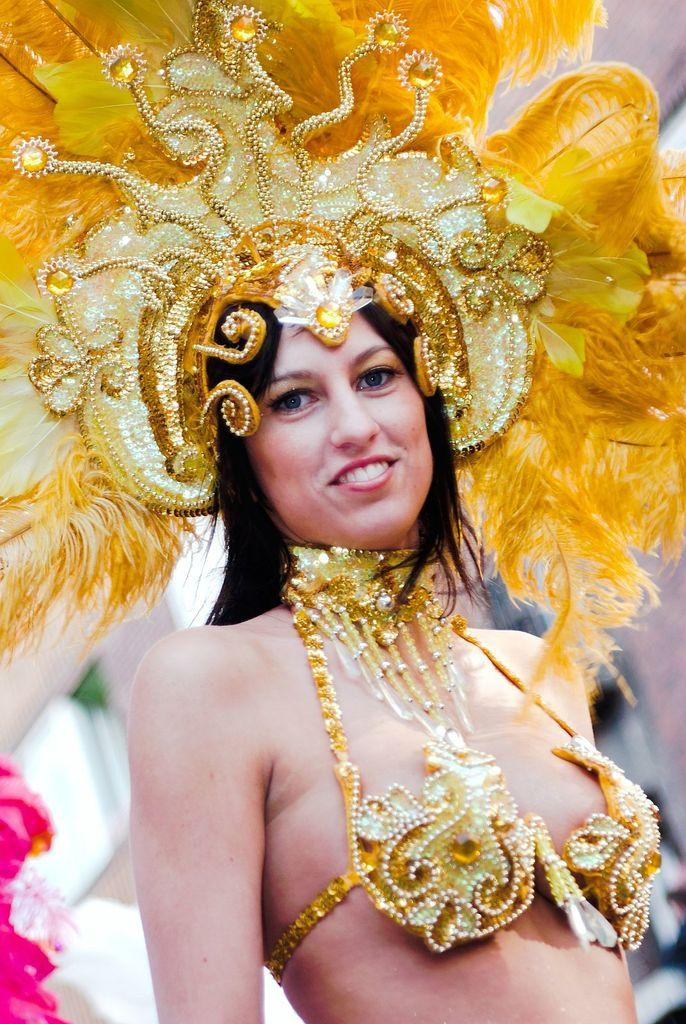Who is the main subject in the image? There is a woman in the image. What is the woman wearing on her head? The woman is wearing a crown. What else is the woman wearing? The woman is wearing a costume. What is the woman's facial expression in the image? The woman is smiling. How would you describe the background of the image? The background of the image is blurry. Can you see a river in the background of the image? There is no river visible in the background of the image. 